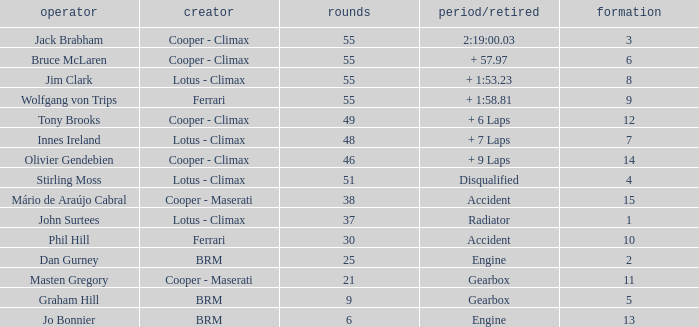Tell me the laps for 3 grids 55.0. 